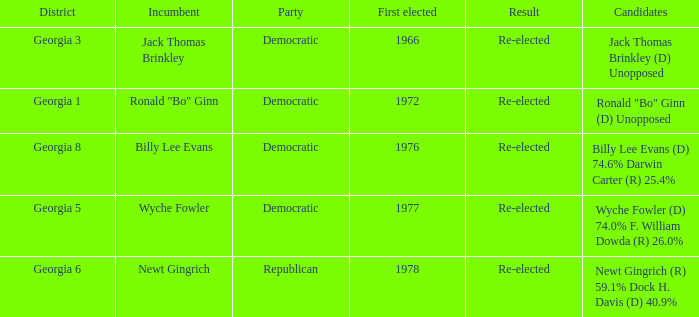How many incumbents were for district georgia 6? 1.0. 